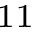Convert formula to latex. <formula><loc_0><loc_0><loc_500><loc_500>^ { 1 1 }</formula> 